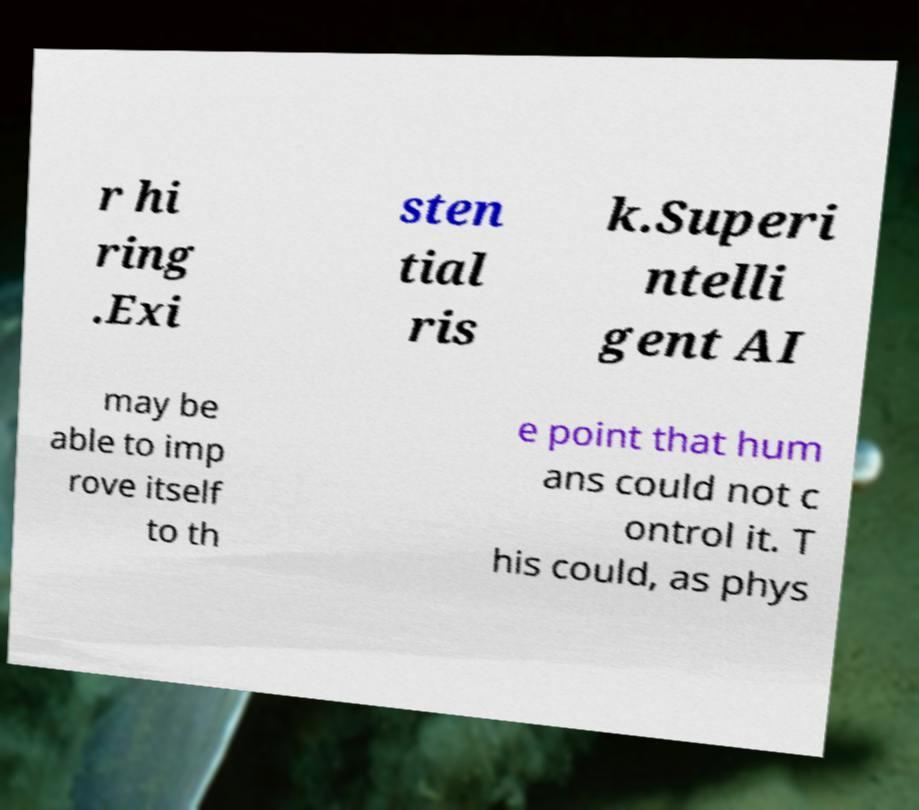What messages or text are displayed in this image? I need them in a readable, typed format. r hi ring .Exi sten tial ris k.Superi ntelli gent AI may be able to imp rove itself to th e point that hum ans could not c ontrol it. T his could, as phys 